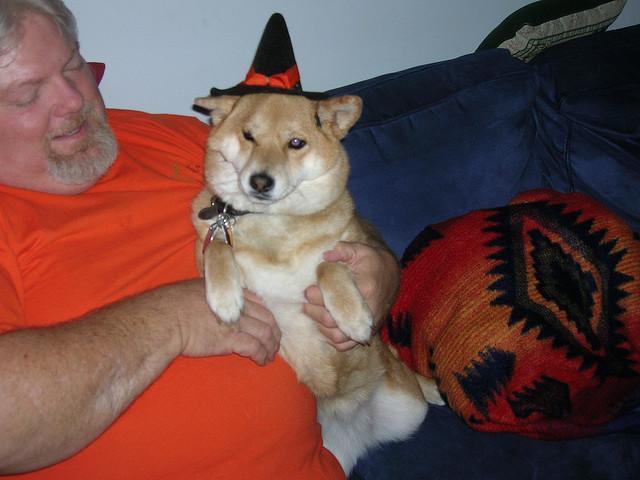How many animals are in this pick?
Give a very brief answer. 1. How many couches can you see?
Give a very brief answer. 1. How many giraffes are standing?
Give a very brief answer. 0. 